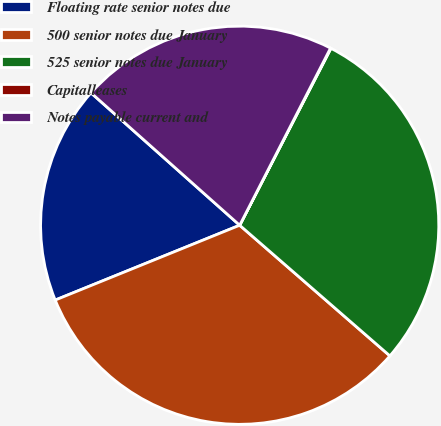Convert chart. <chart><loc_0><loc_0><loc_500><loc_500><pie_chart><fcel>Floating rate senior notes due<fcel>500 senior notes due January<fcel>525 senior notes due January<fcel>Capitalleases<fcel>Notes payable current and<nl><fcel>17.71%<fcel>32.47%<fcel>28.81%<fcel>0.04%<fcel>20.96%<nl></chart> 